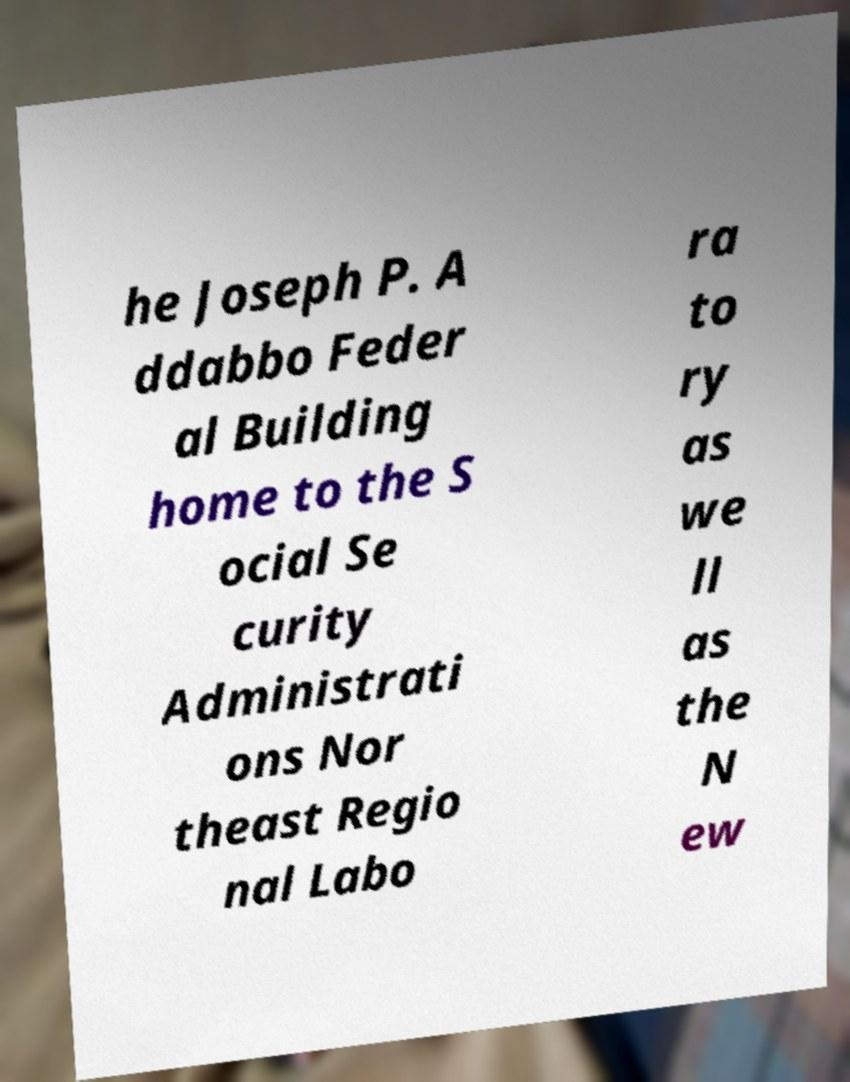Please read and relay the text visible in this image. What does it say? he Joseph P. A ddabbo Feder al Building home to the S ocial Se curity Administrati ons Nor theast Regio nal Labo ra to ry as we ll as the N ew 